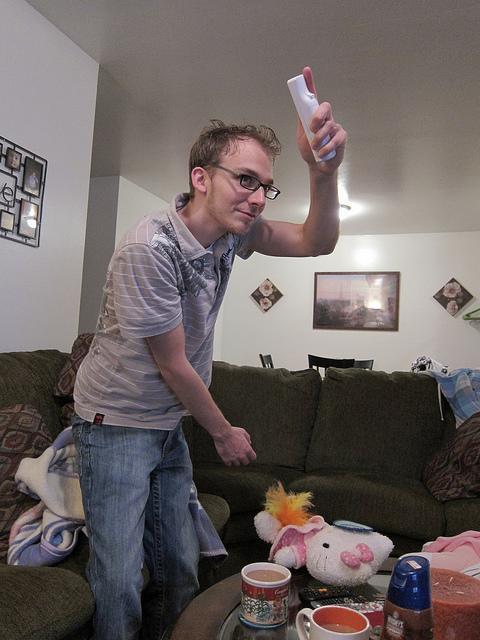How many people are wearing glasses?
Give a very brief answer. 1. How many cups are in the picture?
Give a very brief answer. 2. How many giraffes are not drinking?
Give a very brief answer. 0. 